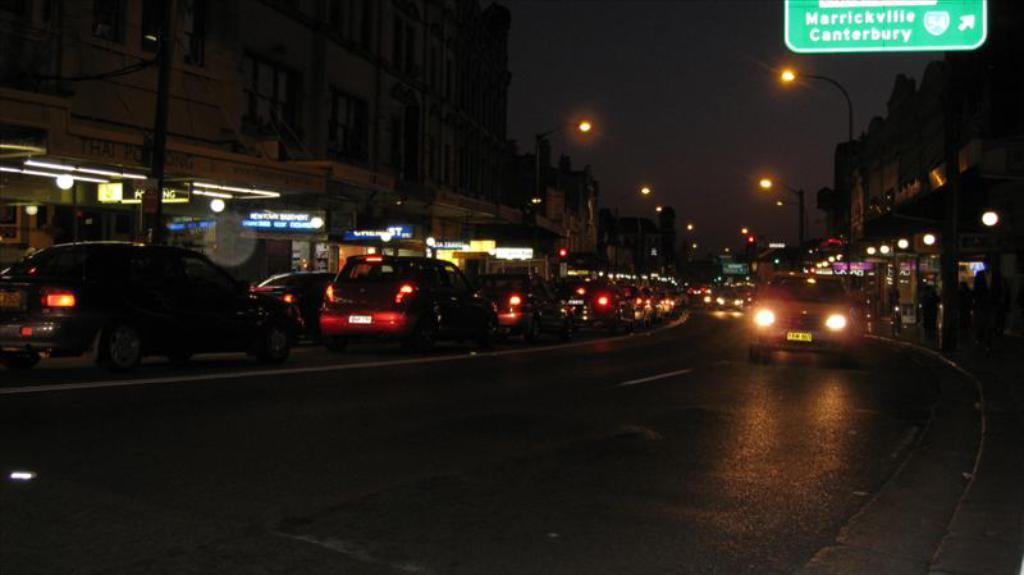What can be seen on the road in the image? There are vehicles on the road in the image. What is located on the right side of the image? There are buildings, stores, persons, and lights on the right side of the image. What is located on the left side of the image? There are buildings, stores, persons, and lights on the left side of the image. What can be seen in the background of the image? The sky is visible in the background of the image. How many brothers are depicted in the image? There are no brothers mentioned or depicted in the image. What type of leaf can be seen falling from the sky in the image? There are no leaves present in the image, and the sky is visible but not showing any falling leaves. 